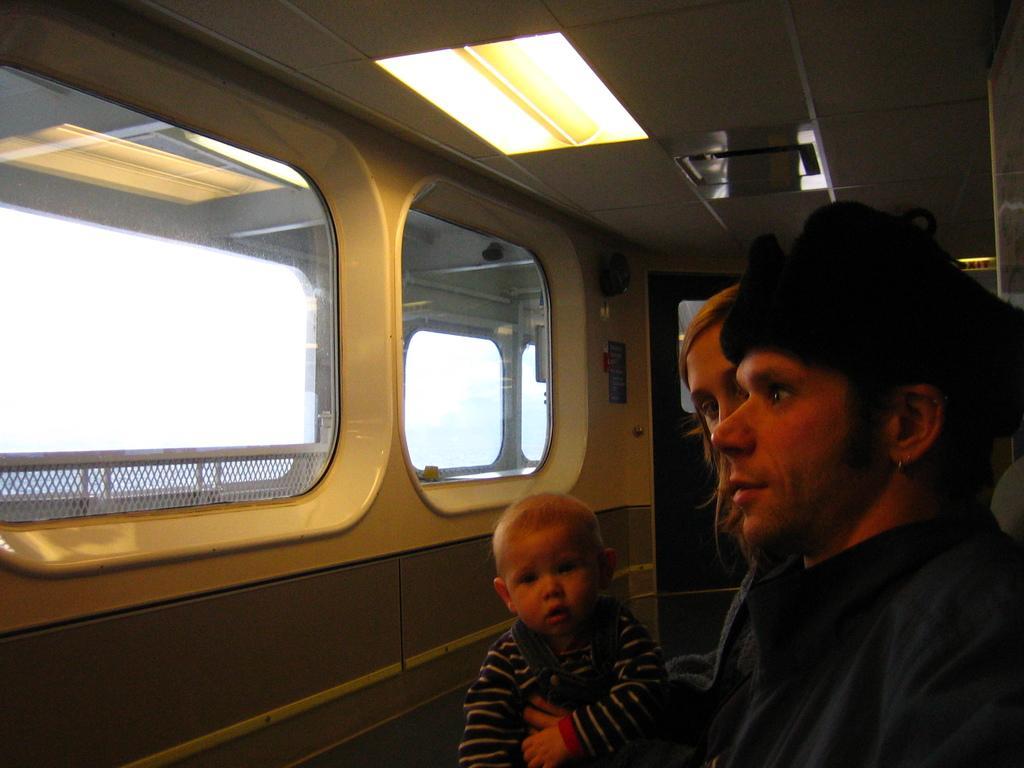Can you describe this image briefly? In this image we can see three persons in the vehicle, at the top we can see the lights, through the windows, we can see the sky. 